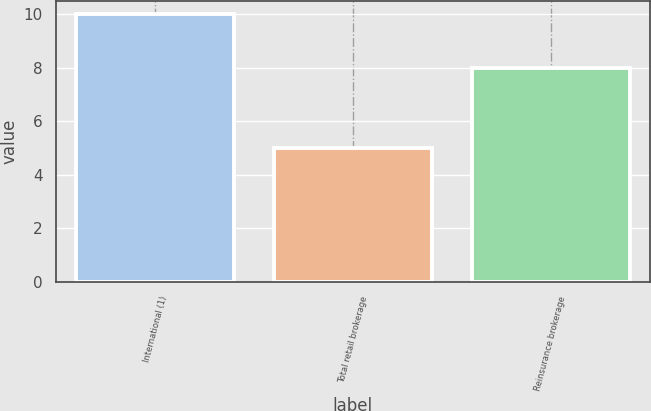Convert chart. <chart><loc_0><loc_0><loc_500><loc_500><bar_chart><fcel>International (1)<fcel>Total retail brokerage<fcel>Reinsurance brokerage<nl><fcel>10<fcel>5<fcel>8<nl></chart> 